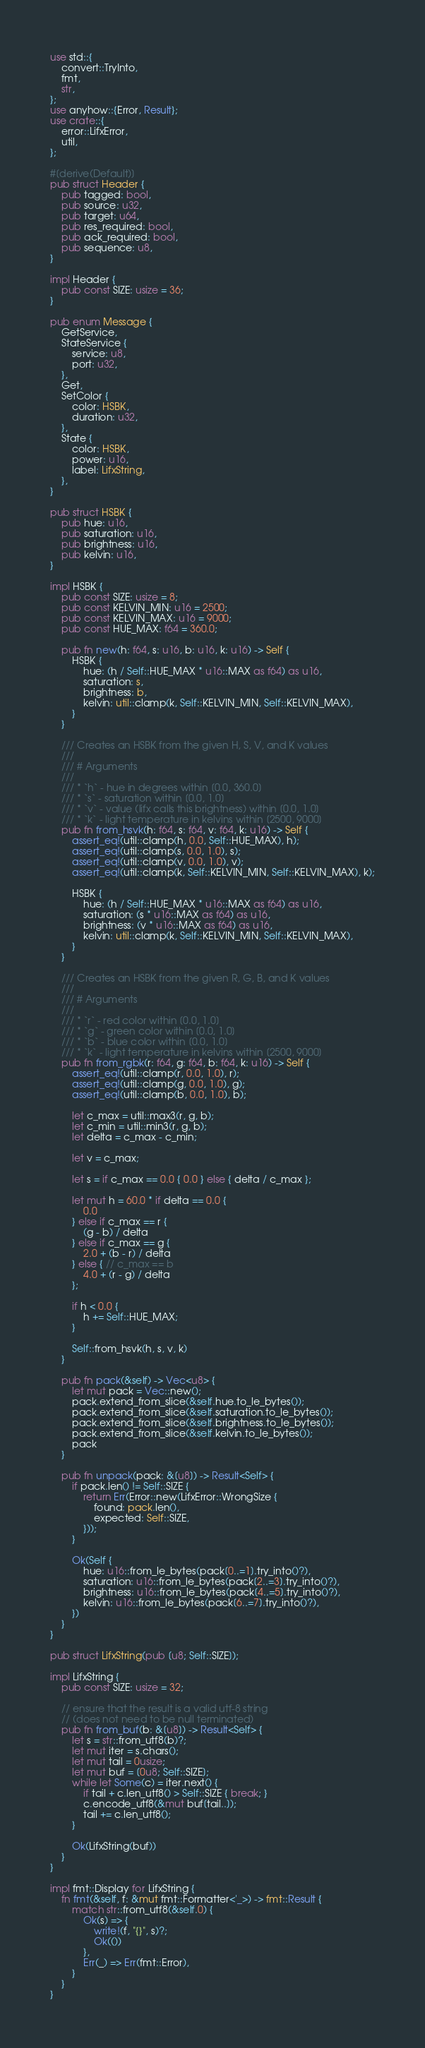Convert code to text. <code><loc_0><loc_0><loc_500><loc_500><_Rust_>use std::{
    convert::TryInto,
    fmt,
    str,
};
use anyhow::{Error, Result};
use crate::{
    error::LifxError,
    util,
};

#[derive(Default)]
pub struct Header {
    pub tagged: bool,
    pub source: u32,
    pub target: u64,
    pub res_required: bool,
    pub ack_required: bool,
    pub sequence: u8,
}

impl Header {
    pub const SIZE: usize = 36;
}

pub enum Message {
    GetService,
    StateService {
        service: u8,
        port: u32,
    },
    Get,
    SetColor {
        color: HSBK,
        duration: u32,
    },
    State {
        color: HSBK,
        power: u16,
        label: LifxString,
    },
}

pub struct HSBK {
    pub hue: u16,
    pub saturation: u16,
    pub brightness: u16,
    pub kelvin: u16,
}

impl HSBK {
    pub const SIZE: usize = 8;
    pub const KELVIN_MIN: u16 = 2500;
    pub const KELVIN_MAX: u16 = 9000;
    pub const HUE_MAX: f64 = 360.0;

    pub fn new(h: f64, s: u16, b: u16, k: u16) -> Self {
        HSBK {
            hue: (h / Self::HUE_MAX * u16::MAX as f64) as u16,
            saturation: s,
            brightness: b,
            kelvin: util::clamp(k, Self::KELVIN_MIN, Self::KELVIN_MAX),
        }
    }

    /// Creates an HSBK from the given H, S, V, and K values
    ///
    /// # Arguments
    ///
    /// * `h` - hue in degrees within [0.0, 360.0]
    /// * `s` - saturation within [0.0, 1.0]
    /// * `v` - value (lifx calls this brightness) within [0.0, 1.0]
    /// * `k` - light temperature in kelvins within [2500, 9000]
    pub fn from_hsvk(h: f64, s: f64, v: f64, k: u16) -> Self {
        assert_eq!(util::clamp(h, 0.0, Self::HUE_MAX), h);
        assert_eq!(util::clamp(s, 0.0, 1.0), s);
        assert_eq!(util::clamp(v, 0.0, 1.0), v);
        assert_eq!(util::clamp(k, Self::KELVIN_MIN, Self::KELVIN_MAX), k);

        HSBK {
            hue: (h / Self::HUE_MAX * u16::MAX as f64) as u16,
            saturation: (s * u16::MAX as f64) as u16,
            brightness: (v * u16::MAX as f64) as u16,
            kelvin: util::clamp(k, Self::KELVIN_MIN, Self::KELVIN_MAX),
        }
    }

    /// Creates an HSBK from the given R, G, B, and K values
    ///
    /// # Arguments
    ///
    /// * `r` - red color within [0.0, 1.0]
    /// * `g` - green color within [0.0, 1.0]
    /// * `b` - blue color within [0.0, 1.0]
    /// * `k` - light temperature in kelvins within [2500, 9000]
    pub fn from_rgbk(r: f64, g: f64, b: f64, k: u16) -> Self {
        assert_eq!(util::clamp(r, 0.0, 1.0), r);
        assert_eq!(util::clamp(g, 0.0, 1.0), g);
        assert_eq!(util::clamp(b, 0.0, 1.0), b);

        let c_max = util::max3(r, g, b);
        let c_min = util::min3(r, g, b);
        let delta = c_max - c_min;

        let v = c_max;

        let s = if c_max == 0.0 { 0.0 } else { delta / c_max };

        let mut h = 60.0 * if delta == 0.0 {
            0.0
        } else if c_max == r {
            (g - b) / delta
        } else if c_max == g {
            2.0 + (b - r) / delta
        } else { // c_max == b
            4.0 + (r - g) / delta
        };

        if h < 0.0 {
            h += Self::HUE_MAX;
        }

        Self::from_hsvk(h, s, v, k)
    }

    pub fn pack(&self) -> Vec<u8> {
        let mut pack = Vec::new();
        pack.extend_from_slice(&self.hue.to_le_bytes());
        pack.extend_from_slice(&self.saturation.to_le_bytes());
        pack.extend_from_slice(&self.brightness.to_le_bytes());
        pack.extend_from_slice(&self.kelvin.to_le_bytes());
        pack
    }

    pub fn unpack(pack: &[u8]) -> Result<Self> {
        if pack.len() != Self::SIZE {
            return Err(Error::new(LifxError::WrongSize {
                found: pack.len(),
                expected: Self::SIZE,
            }));
        }

        Ok(Self {
            hue: u16::from_le_bytes(pack[0..=1].try_into()?),
            saturation: u16::from_le_bytes(pack[2..=3].try_into()?),
            brightness: u16::from_le_bytes(pack[4..=5].try_into()?),
            kelvin: u16::from_le_bytes(pack[6..=7].try_into()?),
        })
    }
}

pub struct LifxString(pub [u8; Self::SIZE]);

impl LifxString {
    pub const SIZE: usize = 32;

    // ensure that the result is a valid utf-8 string
    // (does not need to be null terminated)
    pub fn from_buf(b: &[u8]) -> Result<Self> {
        let s = str::from_utf8(b)?;
        let mut iter = s.chars();
        let mut tail = 0usize;
        let mut buf = [0u8; Self::SIZE];
        while let Some(c) = iter.next() {
            if tail + c.len_utf8() > Self::SIZE { break; }
            c.encode_utf8(&mut buf[tail..]);
            tail += c.len_utf8();
        }

        Ok(LifxString(buf))
    }
}

impl fmt::Display for LifxString {
    fn fmt(&self, f: &mut fmt::Formatter<'_>) -> fmt::Result {
        match str::from_utf8(&self.0) {
            Ok(s) => {
                write!(f, "{}", s)?;
                Ok(())
            },
            Err(_) => Err(fmt::Error),
        }
    }
}
</code> 